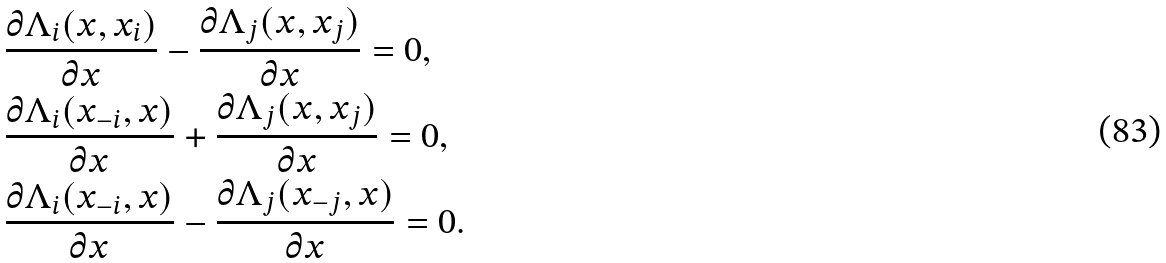Convert formula to latex. <formula><loc_0><loc_0><loc_500><loc_500>& \frac { \partial \Lambda _ { i } ( x , x _ { i } ) } { \partial x } - \frac { \partial \Lambda _ { j } ( x , x _ { j } ) } { \partial x } = 0 , \\ & \frac { \partial \Lambda _ { i } ( x _ { - i } , x ) } { \partial x } + \frac { \partial \Lambda _ { j } ( x , x _ { j } ) } { \partial x } = 0 , \\ & \frac { \partial \Lambda _ { i } ( x _ { - i } , x ) } { \partial x } - \frac { \partial \Lambda _ { j } ( x _ { - j } , x ) } { \partial x } = 0 .</formula> 